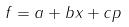<formula> <loc_0><loc_0><loc_500><loc_500>f = a + b x + c p</formula> 